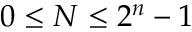Convert formula to latex. <formula><loc_0><loc_0><loc_500><loc_500>0 \leq N \leq 2 ^ { n } - 1</formula> 